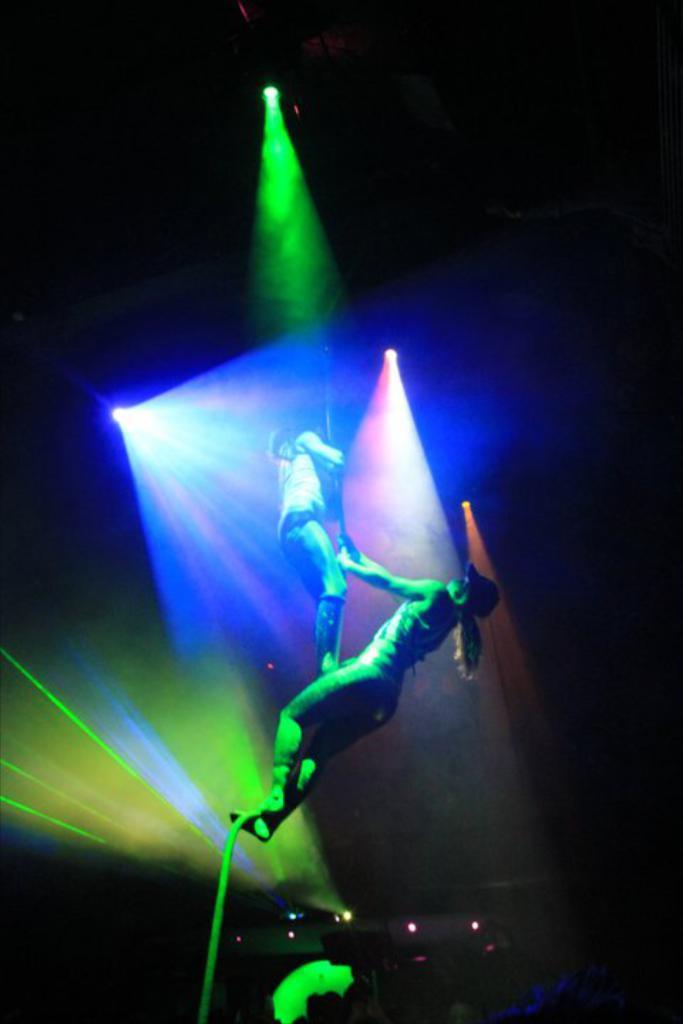Where was the image taken? The image was taken indoors. What can be observed about the lighting in the image? The background of the image is dark. What is the main source of light in the image? There are a few lights in the middle of the image. What are the two women in the image doing? The women are dancing in the image. What are the women holding while dancing? The women are holding a pole. In which direction are the women riding their bikes in the image? There are no bikes present in the image; the women are dancing and holding a pole. 